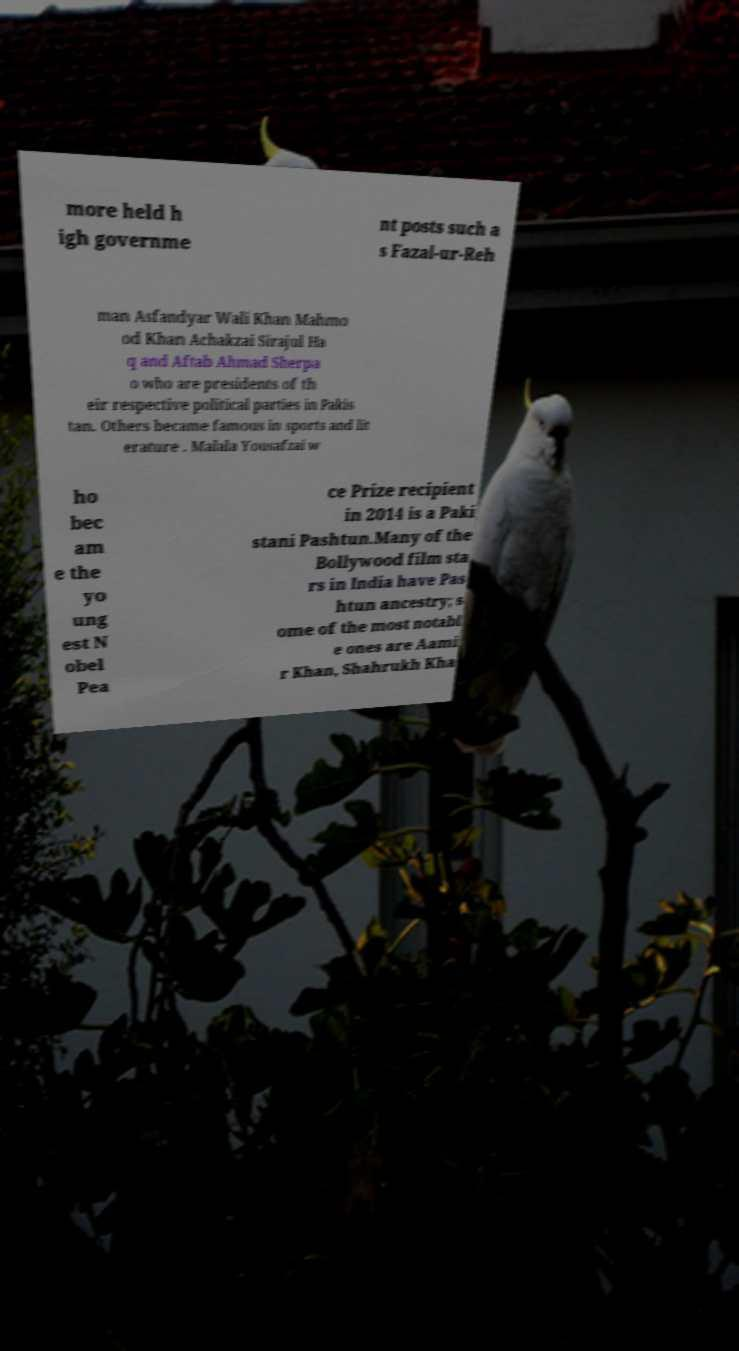There's text embedded in this image that I need extracted. Can you transcribe it verbatim? more held h igh governme nt posts such a s Fazal-ur-Reh man Asfandyar Wali Khan Mahmo od Khan Achakzai Sirajul Ha q and Aftab Ahmad Sherpa o who are presidents of th eir respective political parties in Pakis tan. Others became famous in sports and lit erature . Malala Yousafzai w ho bec am e the yo ung est N obel Pea ce Prize recipient in 2014 is a Paki stani Pashtun.Many of the Bollywood film sta rs in India have Pas htun ancestry; s ome of the most notabl e ones are Aami r Khan, Shahrukh Kha 